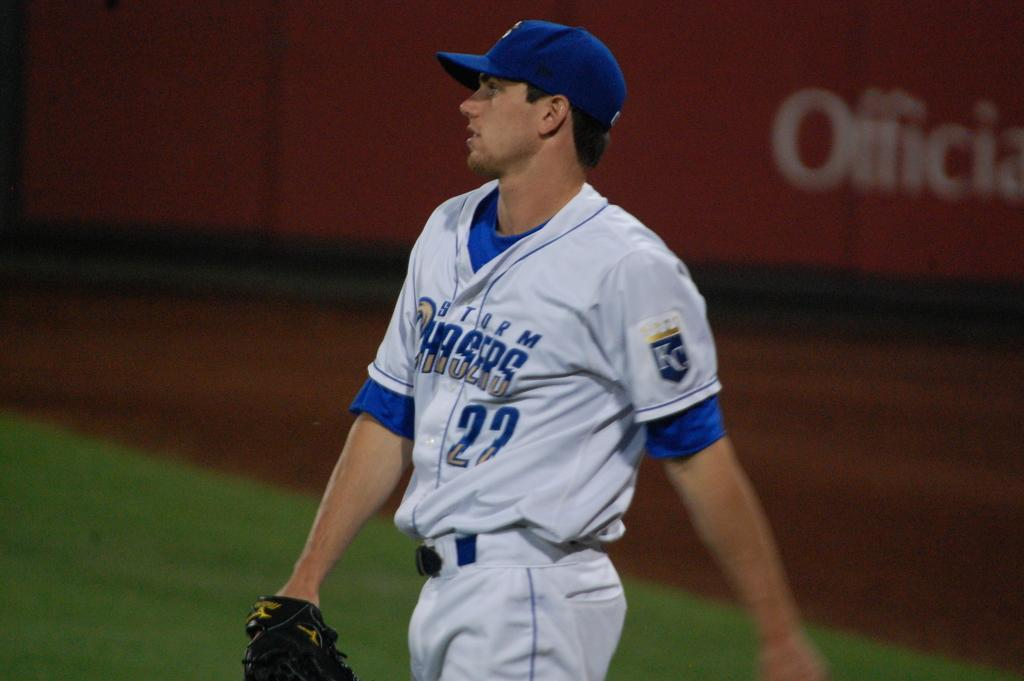<image>
Describe the image concisely. A baseball player with the words Storm Chasers on his jersey. 